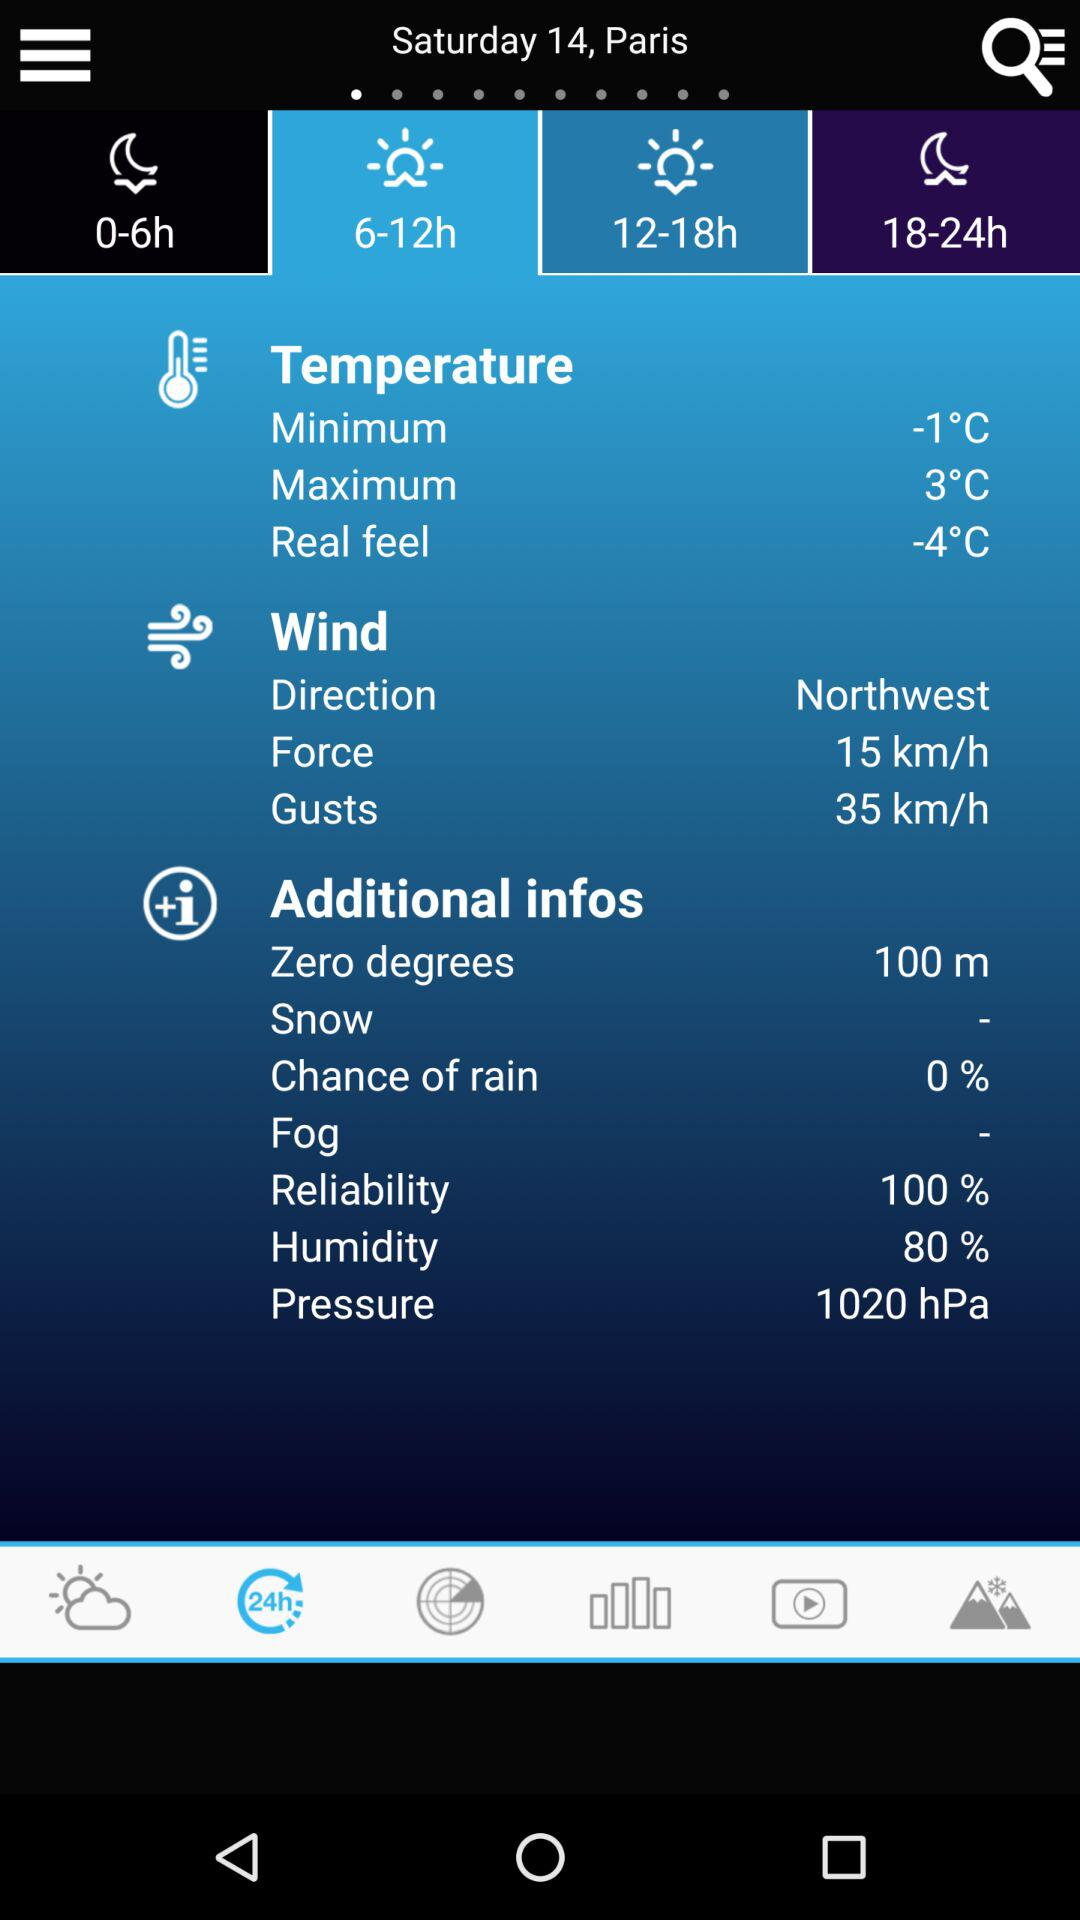What is the maximum temperature? The maximum temperature is 3 °C. 